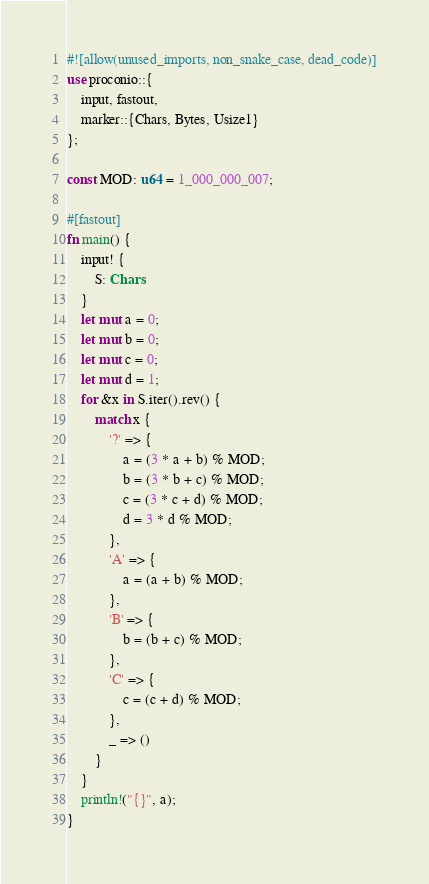Convert code to text. <code><loc_0><loc_0><loc_500><loc_500><_Rust_>#![allow(unused_imports, non_snake_case, dead_code)]
use proconio::{
    input, fastout,
    marker::{Chars, Bytes, Usize1}
};

const MOD: u64 = 1_000_000_007;

#[fastout]
fn main() {
    input! {
        S: Chars
    }
    let mut a = 0;
    let mut b = 0;
    let mut c = 0;
    let mut d = 1;
    for &x in S.iter().rev() {
        match x {
            '?' => {
                a = (3 * a + b) % MOD;
                b = (3 * b + c) % MOD;
                c = (3 * c + d) % MOD;
                d = 3 * d % MOD;
            },
            'A' => {
                a = (a + b) % MOD;
            },
            'B' => {
                b = (b + c) % MOD;
            },
            'C' => {
                c = (c + d) % MOD;
            },
            _ => ()
        }
    }
    println!("{}", a);
}</code> 